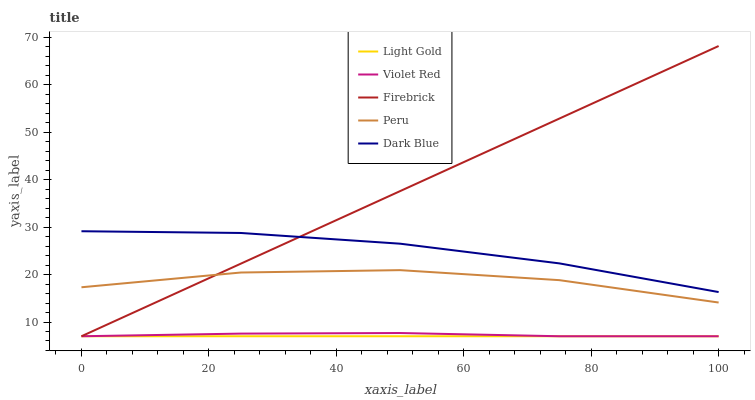Does Light Gold have the minimum area under the curve?
Answer yes or no. Yes. Does Firebrick have the maximum area under the curve?
Answer yes or no. Yes. Does Violet Red have the minimum area under the curve?
Answer yes or no. No. Does Violet Red have the maximum area under the curve?
Answer yes or no. No. Is Light Gold the smoothest?
Answer yes or no. Yes. Is Peru the roughest?
Answer yes or no. Yes. Is Violet Red the smoothest?
Answer yes or no. No. Is Violet Red the roughest?
Answer yes or no. No. Does Violet Red have the lowest value?
Answer yes or no. Yes. Does Peru have the lowest value?
Answer yes or no. No. Does Firebrick have the highest value?
Answer yes or no. Yes. Does Violet Red have the highest value?
Answer yes or no. No. Is Light Gold less than Dark Blue?
Answer yes or no. Yes. Is Dark Blue greater than Light Gold?
Answer yes or no. Yes. Does Light Gold intersect Firebrick?
Answer yes or no. Yes. Is Light Gold less than Firebrick?
Answer yes or no. No. Is Light Gold greater than Firebrick?
Answer yes or no. No. Does Light Gold intersect Dark Blue?
Answer yes or no. No. 